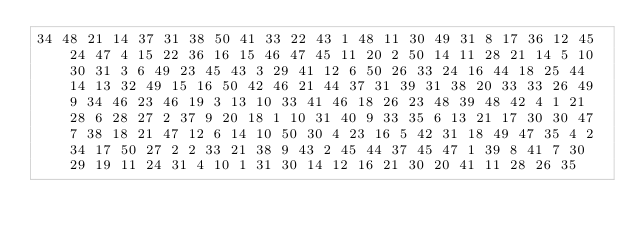<code> <loc_0><loc_0><loc_500><loc_500><_Matlab_>34 48 21 14 37 31 38 50 41 33 22 43 1 48 11 30 49 31 8 17 36 12 45 24 47 4 15 22 36 16 15 46 47 45 11 20 2 50 14 11 28 21 14 5 10 30 31 3 6 49 23 45 43 3 29 41 12 6 50 26 33 24 16 44 18 25 44 14 13 32 49 15 16 50 42 46 21 44 37 31 39 31 38 20 33 33 26 49 9 34 46 23 46 19 3 13 10 33 41 46 18 26 23 48 39 48 42 4 1 21 28 6 28 27 2 37 9 20 18 1 10 31 40 9 33 35 6 13 21 17 30 30 47 7 38 18 21 47 12 6 14 10 50 30 4 23 16 5 42 31 18 49 47 35 4 2 34 17 50 27 2 2 33 21 38 9 43 2 45 44 37 45 47 1 39 8 41 7 30 29 19 11 24 31 4 10 1 31 30 14 12 16 21 30 20 41 11 28 26 35</code> 